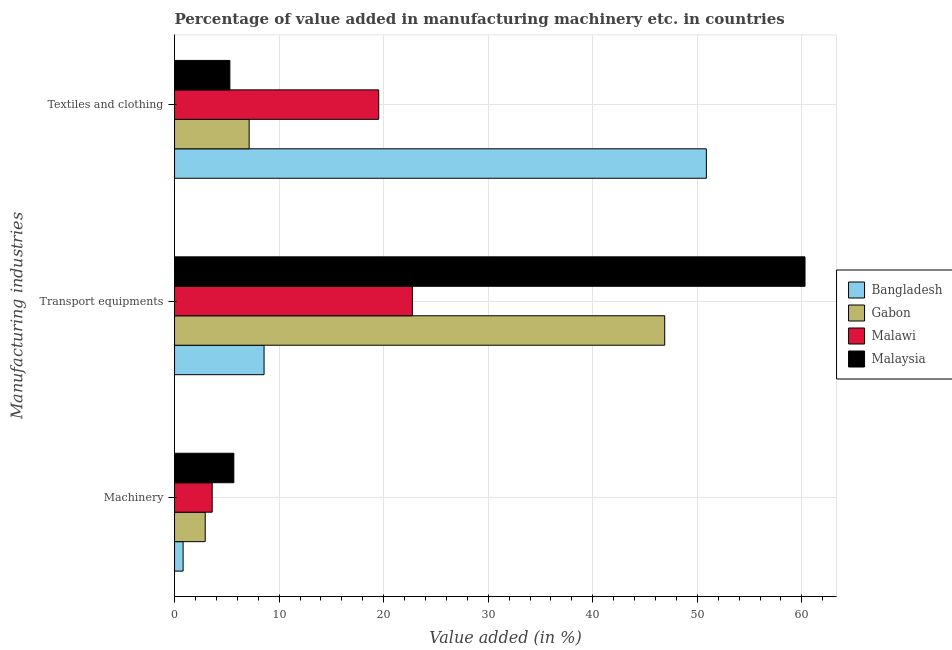How many groups of bars are there?
Keep it short and to the point. 3. Are the number of bars per tick equal to the number of legend labels?
Your answer should be very brief. Yes. Are the number of bars on each tick of the Y-axis equal?
Provide a short and direct response. Yes. What is the label of the 2nd group of bars from the top?
Ensure brevity in your answer.  Transport equipments. What is the value added in manufacturing machinery in Malaysia?
Ensure brevity in your answer.  5.67. Across all countries, what is the maximum value added in manufacturing machinery?
Your answer should be compact. 5.67. Across all countries, what is the minimum value added in manufacturing machinery?
Provide a short and direct response. 0.82. In which country was the value added in manufacturing textile and clothing minimum?
Your answer should be very brief. Malaysia. What is the total value added in manufacturing textile and clothing in the graph?
Give a very brief answer. 82.82. What is the difference between the value added in manufacturing transport equipments in Bangladesh and that in Malaysia?
Provide a succinct answer. -51.74. What is the difference between the value added in manufacturing machinery in Bangladesh and the value added in manufacturing textile and clothing in Malawi?
Give a very brief answer. -18.71. What is the average value added in manufacturing machinery per country?
Ensure brevity in your answer.  3.26. What is the difference between the value added in manufacturing textile and clothing and value added in manufacturing machinery in Gabon?
Provide a succinct answer. 4.2. What is the ratio of the value added in manufacturing machinery in Bangladesh to that in Gabon?
Keep it short and to the point. 0.28. Is the value added in manufacturing transport equipments in Bangladesh less than that in Malaysia?
Provide a succinct answer. Yes. What is the difference between the highest and the second highest value added in manufacturing machinery?
Provide a short and direct response. 2.07. What is the difference between the highest and the lowest value added in manufacturing machinery?
Provide a succinct answer. 4.85. In how many countries, is the value added in manufacturing textile and clothing greater than the average value added in manufacturing textile and clothing taken over all countries?
Give a very brief answer. 1. What does the 3rd bar from the top in Machinery represents?
Your response must be concise. Gabon. What does the 1st bar from the bottom in Textiles and clothing represents?
Offer a very short reply. Bangladesh. Is it the case that in every country, the sum of the value added in manufacturing machinery and value added in manufacturing transport equipments is greater than the value added in manufacturing textile and clothing?
Make the answer very short. No. How many countries are there in the graph?
Your answer should be very brief. 4. Are the values on the major ticks of X-axis written in scientific E-notation?
Offer a terse response. No. Does the graph contain any zero values?
Offer a very short reply. No. How many legend labels are there?
Ensure brevity in your answer.  4. What is the title of the graph?
Your response must be concise. Percentage of value added in manufacturing machinery etc. in countries. Does "Montenegro" appear as one of the legend labels in the graph?
Your answer should be compact. No. What is the label or title of the X-axis?
Your response must be concise. Value added (in %). What is the label or title of the Y-axis?
Offer a very short reply. Manufacturing industries. What is the Value added (in %) in Bangladesh in Machinery?
Your answer should be very brief. 0.82. What is the Value added (in %) in Gabon in Machinery?
Offer a terse response. 2.93. What is the Value added (in %) in Malawi in Machinery?
Offer a terse response. 3.6. What is the Value added (in %) of Malaysia in Machinery?
Give a very brief answer. 5.67. What is the Value added (in %) in Bangladesh in Transport equipments?
Offer a very short reply. 8.56. What is the Value added (in %) in Gabon in Transport equipments?
Make the answer very short. 46.88. What is the Value added (in %) of Malawi in Transport equipments?
Make the answer very short. 22.75. What is the Value added (in %) of Malaysia in Transport equipments?
Keep it short and to the point. 60.3. What is the Value added (in %) of Bangladesh in Textiles and clothing?
Offer a very short reply. 50.87. What is the Value added (in %) in Gabon in Textiles and clothing?
Provide a short and direct response. 7.14. What is the Value added (in %) in Malawi in Textiles and clothing?
Ensure brevity in your answer.  19.53. What is the Value added (in %) in Malaysia in Textiles and clothing?
Ensure brevity in your answer.  5.29. Across all Manufacturing industries, what is the maximum Value added (in %) in Bangladesh?
Give a very brief answer. 50.87. Across all Manufacturing industries, what is the maximum Value added (in %) of Gabon?
Your answer should be very brief. 46.88. Across all Manufacturing industries, what is the maximum Value added (in %) of Malawi?
Offer a terse response. 22.75. Across all Manufacturing industries, what is the maximum Value added (in %) in Malaysia?
Your answer should be very brief. 60.3. Across all Manufacturing industries, what is the minimum Value added (in %) in Bangladesh?
Provide a short and direct response. 0.82. Across all Manufacturing industries, what is the minimum Value added (in %) of Gabon?
Give a very brief answer. 2.93. Across all Manufacturing industries, what is the minimum Value added (in %) of Malawi?
Provide a succinct answer. 3.6. Across all Manufacturing industries, what is the minimum Value added (in %) in Malaysia?
Your response must be concise. 5.29. What is the total Value added (in %) in Bangladesh in the graph?
Keep it short and to the point. 60.25. What is the total Value added (in %) in Gabon in the graph?
Make the answer very short. 56.95. What is the total Value added (in %) of Malawi in the graph?
Provide a succinct answer. 45.88. What is the total Value added (in %) in Malaysia in the graph?
Your answer should be compact. 71.26. What is the difference between the Value added (in %) in Bangladesh in Machinery and that in Transport equipments?
Your answer should be very brief. -7.74. What is the difference between the Value added (in %) in Gabon in Machinery and that in Transport equipments?
Offer a terse response. -43.95. What is the difference between the Value added (in %) of Malawi in Machinery and that in Transport equipments?
Give a very brief answer. -19.15. What is the difference between the Value added (in %) in Malaysia in Machinery and that in Transport equipments?
Offer a very short reply. -54.63. What is the difference between the Value added (in %) of Bangladesh in Machinery and that in Textiles and clothing?
Ensure brevity in your answer.  -50.05. What is the difference between the Value added (in %) in Gabon in Machinery and that in Textiles and clothing?
Offer a terse response. -4.2. What is the difference between the Value added (in %) in Malawi in Machinery and that in Textiles and clothing?
Offer a very short reply. -15.93. What is the difference between the Value added (in %) in Malaysia in Machinery and that in Textiles and clothing?
Your answer should be compact. 0.38. What is the difference between the Value added (in %) of Bangladesh in Transport equipments and that in Textiles and clothing?
Ensure brevity in your answer.  -42.3. What is the difference between the Value added (in %) in Gabon in Transport equipments and that in Textiles and clothing?
Provide a short and direct response. 39.75. What is the difference between the Value added (in %) of Malawi in Transport equipments and that in Textiles and clothing?
Keep it short and to the point. 3.22. What is the difference between the Value added (in %) of Malaysia in Transport equipments and that in Textiles and clothing?
Give a very brief answer. 55.01. What is the difference between the Value added (in %) of Bangladesh in Machinery and the Value added (in %) of Gabon in Transport equipments?
Keep it short and to the point. -46.06. What is the difference between the Value added (in %) of Bangladesh in Machinery and the Value added (in %) of Malawi in Transport equipments?
Provide a short and direct response. -21.93. What is the difference between the Value added (in %) in Bangladesh in Machinery and the Value added (in %) in Malaysia in Transport equipments?
Your response must be concise. -59.48. What is the difference between the Value added (in %) in Gabon in Machinery and the Value added (in %) in Malawi in Transport equipments?
Your answer should be compact. -19.81. What is the difference between the Value added (in %) of Gabon in Machinery and the Value added (in %) of Malaysia in Transport equipments?
Your response must be concise. -57.37. What is the difference between the Value added (in %) in Malawi in Machinery and the Value added (in %) in Malaysia in Transport equipments?
Provide a succinct answer. -56.7. What is the difference between the Value added (in %) in Bangladesh in Machinery and the Value added (in %) in Gabon in Textiles and clothing?
Keep it short and to the point. -6.32. What is the difference between the Value added (in %) of Bangladesh in Machinery and the Value added (in %) of Malawi in Textiles and clothing?
Your answer should be compact. -18.71. What is the difference between the Value added (in %) in Bangladesh in Machinery and the Value added (in %) in Malaysia in Textiles and clothing?
Your response must be concise. -4.47. What is the difference between the Value added (in %) of Gabon in Machinery and the Value added (in %) of Malawi in Textiles and clothing?
Make the answer very short. -16.59. What is the difference between the Value added (in %) of Gabon in Machinery and the Value added (in %) of Malaysia in Textiles and clothing?
Offer a very short reply. -2.36. What is the difference between the Value added (in %) in Malawi in Machinery and the Value added (in %) in Malaysia in Textiles and clothing?
Give a very brief answer. -1.69. What is the difference between the Value added (in %) of Bangladesh in Transport equipments and the Value added (in %) of Gabon in Textiles and clothing?
Keep it short and to the point. 1.43. What is the difference between the Value added (in %) in Bangladesh in Transport equipments and the Value added (in %) in Malawi in Textiles and clothing?
Your response must be concise. -10.97. What is the difference between the Value added (in %) in Bangladesh in Transport equipments and the Value added (in %) in Malaysia in Textiles and clothing?
Your answer should be compact. 3.27. What is the difference between the Value added (in %) of Gabon in Transport equipments and the Value added (in %) of Malawi in Textiles and clothing?
Ensure brevity in your answer.  27.35. What is the difference between the Value added (in %) of Gabon in Transport equipments and the Value added (in %) of Malaysia in Textiles and clothing?
Provide a short and direct response. 41.59. What is the difference between the Value added (in %) of Malawi in Transport equipments and the Value added (in %) of Malaysia in Textiles and clothing?
Keep it short and to the point. 17.45. What is the average Value added (in %) in Bangladesh per Manufacturing industries?
Your answer should be very brief. 20.08. What is the average Value added (in %) in Gabon per Manufacturing industries?
Provide a succinct answer. 18.98. What is the average Value added (in %) of Malawi per Manufacturing industries?
Make the answer very short. 15.29. What is the average Value added (in %) of Malaysia per Manufacturing industries?
Provide a short and direct response. 23.75. What is the difference between the Value added (in %) in Bangladesh and Value added (in %) in Gabon in Machinery?
Give a very brief answer. -2.11. What is the difference between the Value added (in %) in Bangladesh and Value added (in %) in Malawi in Machinery?
Ensure brevity in your answer.  -2.78. What is the difference between the Value added (in %) in Bangladesh and Value added (in %) in Malaysia in Machinery?
Your answer should be very brief. -4.85. What is the difference between the Value added (in %) of Gabon and Value added (in %) of Malawi in Machinery?
Your answer should be compact. -0.67. What is the difference between the Value added (in %) of Gabon and Value added (in %) of Malaysia in Machinery?
Your response must be concise. -2.74. What is the difference between the Value added (in %) of Malawi and Value added (in %) of Malaysia in Machinery?
Give a very brief answer. -2.07. What is the difference between the Value added (in %) in Bangladesh and Value added (in %) in Gabon in Transport equipments?
Your response must be concise. -38.32. What is the difference between the Value added (in %) in Bangladesh and Value added (in %) in Malawi in Transport equipments?
Offer a terse response. -14.18. What is the difference between the Value added (in %) in Bangladesh and Value added (in %) in Malaysia in Transport equipments?
Provide a succinct answer. -51.74. What is the difference between the Value added (in %) of Gabon and Value added (in %) of Malawi in Transport equipments?
Offer a terse response. 24.14. What is the difference between the Value added (in %) of Gabon and Value added (in %) of Malaysia in Transport equipments?
Offer a terse response. -13.42. What is the difference between the Value added (in %) in Malawi and Value added (in %) in Malaysia in Transport equipments?
Your answer should be compact. -37.56. What is the difference between the Value added (in %) in Bangladesh and Value added (in %) in Gabon in Textiles and clothing?
Offer a very short reply. 43.73. What is the difference between the Value added (in %) in Bangladesh and Value added (in %) in Malawi in Textiles and clothing?
Offer a terse response. 31.34. What is the difference between the Value added (in %) of Bangladesh and Value added (in %) of Malaysia in Textiles and clothing?
Offer a very short reply. 45.57. What is the difference between the Value added (in %) in Gabon and Value added (in %) in Malawi in Textiles and clothing?
Make the answer very short. -12.39. What is the difference between the Value added (in %) in Gabon and Value added (in %) in Malaysia in Textiles and clothing?
Offer a very short reply. 1.84. What is the difference between the Value added (in %) in Malawi and Value added (in %) in Malaysia in Textiles and clothing?
Ensure brevity in your answer.  14.24. What is the ratio of the Value added (in %) in Bangladesh in Machinery to that in Transport equipments?
Offer a very short reply. 0.1. What is the ratio of the Value added (in %) of Gabon in Machinery to that in Transport equipments?
Ensure brevity in your answer.  0.06. What is the ratio of the Value added (in %) in Malawi in Machinery to that in Transport equipments?
Give a very brief answer. 0.16. What is the ratio of the Value added (in %) of Malaysia in Machinery to that in Transport equipments?
Ensure brevity in your answer.  0.09. What is the ratio of the Value added (in %) in Bangladesh in Machinery to that in Textiles and clothing?
Offer a terse response. 0.02. What is the ratio of the Value added (in %) in Gabon in Machinery to that in Textiles and clothing?
Make the answer very short. 0.41. What is the ratio of the Value added (in %) in Malawi in Machinery to that in Textiles and clothing?
Your answer should be very brief. 0.18. What is the ratio of the Value added (in %) in Malaysia in Machinery to that in Textiles and clothing?
Provide a succinct answer. 1.07. What is the ratio of the Value added (in %) in Bangladesh in Transport equipments to that in Textiles and clothing?
Keep it short and to the point. 0.17. What is the ratio of the Value added (in %) of Gabon in Transport equipments to that in Textiles and clothing?
Your answer should be very brief. 6.57. What is the ratio of the Value added (in %) of Malawi in Transport equipments to that in Textiles and clothing?
Provide a short and direct response. 1.16. What is the ratio of the Value added (in %) in Malaysia in Transport equipments to that in Textiles and clothing?
Make the answer very short. 11.4. What is the difference between the highest and the second highest Value added (in %) in Bangladesh?
Your answer should be very brief. 42.3. What is the difference between the highest and the second highest Value added (in %) of Gabon?
Provide a short and direct response. 39.75. What is the difference between the highest and the second highest Value added (in %) of Malawi?
Provide a succinct answer. 3.22. What is the difference between the highest and the second highest Value added (in %) in Malaysia?
Your answer should be compact. 54.63. What is the difference between the highest and the lowest Value added (in %) in Bangladesh?
Provide a short and direct response. 50.05. What is the difference between the highest and the lowest Value added (in %) of Gabon?
Your response must be concise. 43.95. What is the difference between the highest and the lowest Value added (in %) of Malawi?
Make the answer very short. 19.15. What is the difference between the highest and the lowest Value added (in %) of Malaysia?
Offer a very short reply. 55.01. 